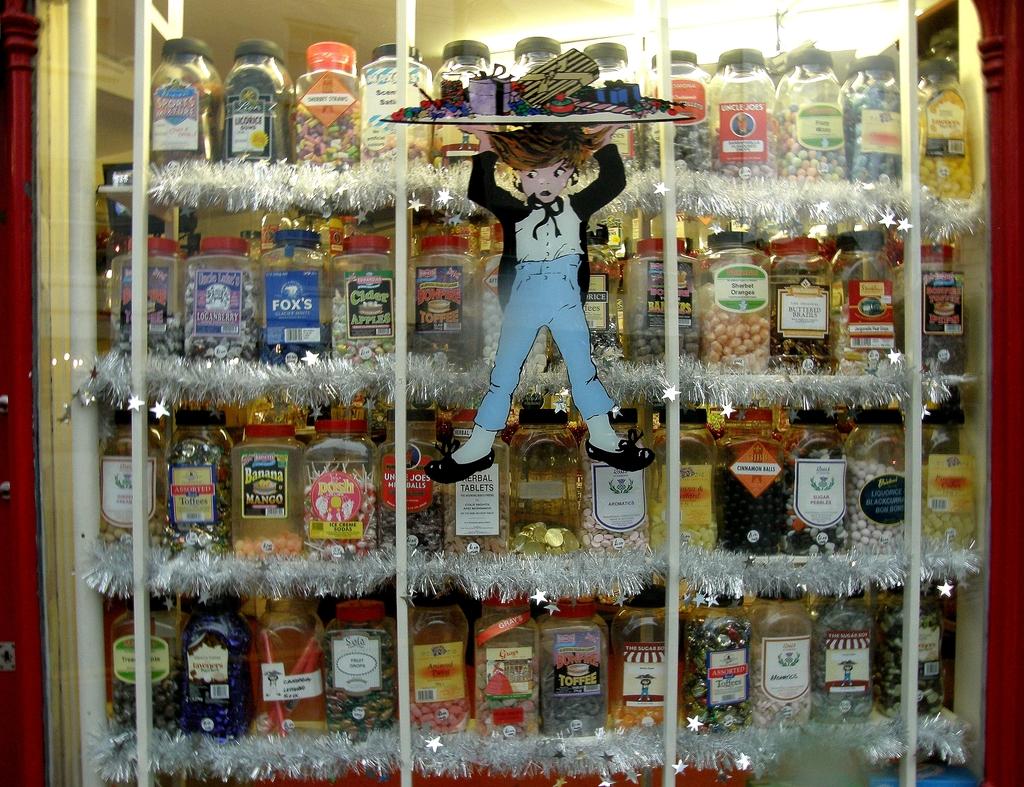What rhymes with "coffee" that is on the bottom shelf?
Give a very brief answer. Toffee. 